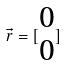<formula> <loc_0><loc_0><loc_500><loc_500>\vec { r } = [ \begin{matrix} 0 \\ 0 \end{matrix} ]</formula> 